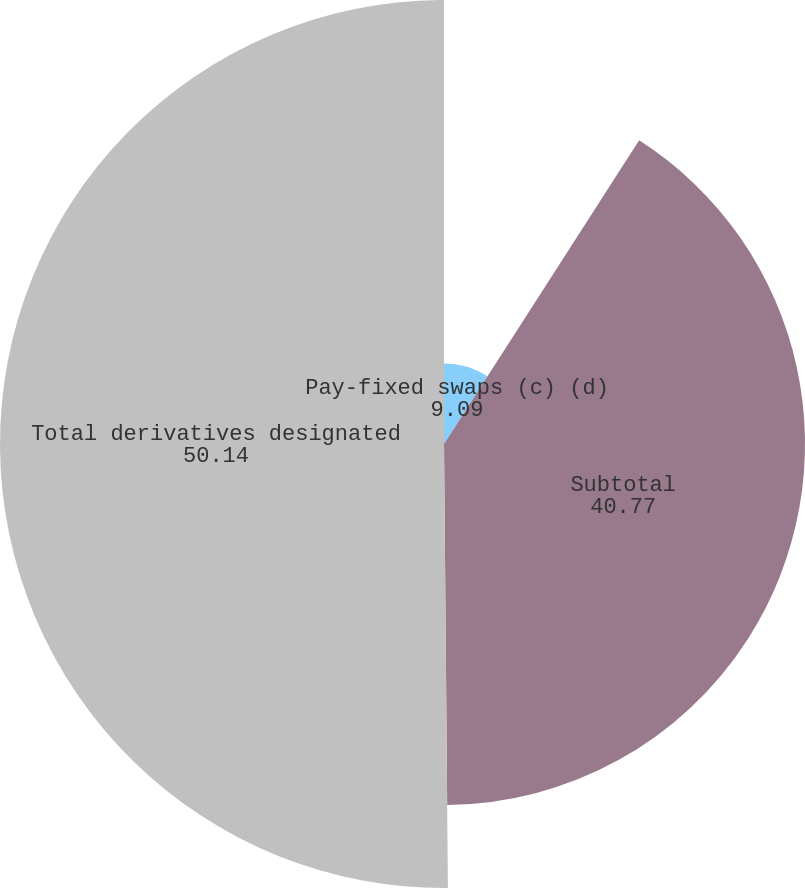Convert chart. <chart><loc_0><loc_0><loc_500><loc_500><pie_chart><fcel>Pay-fixed swaps (c) (d)<fcel>Subtotal<fcel>Total derivatives designated<nl><fcel>9.09%<fcel>40.77%<fcel>50.14%<nl></chart> 